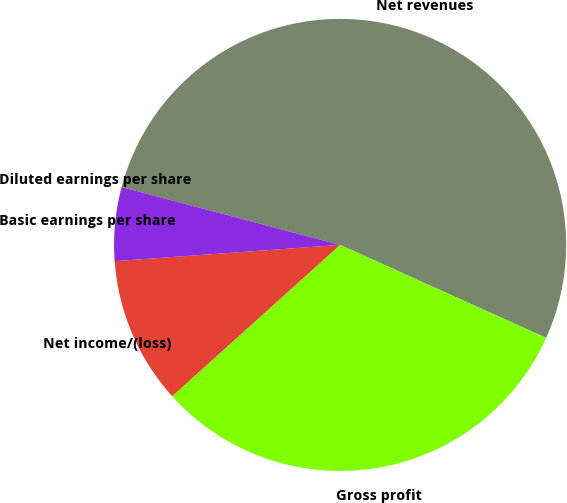Convert chart. <chart><loc_0><loc_0><loc_500><loc_500><pie_chart><fcel>Net revenues<fcel>Gross profit<fcel>Net income/(loss)<fcel>Basic earnings per share<fcel>Diluted earnings per share<nl><fcel>52.63%<fcel>31.58%<fcel>10.53%<fcel>5.26%<fcel>0.0%<nl></chart> 